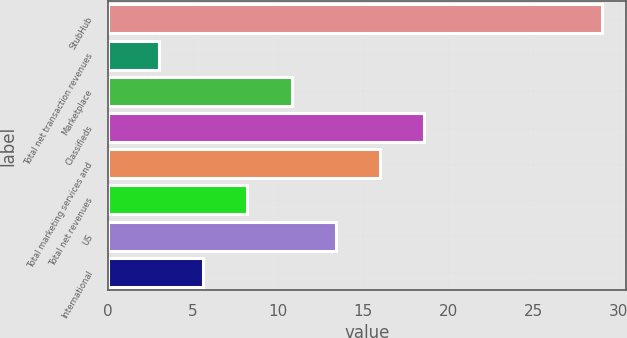<chart> <loc_0><loc_0><loc_500><loc_500><bar_chart><fcel>StubHub<fcel>Total net transaction revenues<fcel>Marketplace<fcel>Classifieds<fcel>Total marketing services and<fcel>Total net revenues<fcel>US<fcel>International<nl><fcel>29<fcel>3<fcel>10.8<fcel>18.6<fcel>16<fcel>8.2<fcel>13.4<fcel>5.6<nl></chart> 